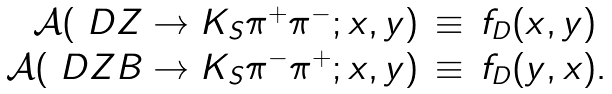Convert formula to latex. <formula><loc_0><loc_0><loc_500><loc_500>\begin{array} { r c l } \mathcal { A } ( \ D Z \rightarrow K _ { S } \pi ^ { + } \pi ^ { - } ; x , y ) & \equiv & f _ { D } ( x , y ) \\ \mathcal { A } ( \ D Z B \rightarrow K _ { S } \pi ^ { - } \pi ^ { + } ; x , y ) & \equiv & f _ { D } ( y , x ) . \\ & & \\ \end{array}</formula> 